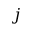Convert formula to latex. <formula><loc_0><loc_0><loc_500><loc_500>j</formula> 